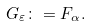<formula> <loc_0><loc_0><loc_500><loc_500>G _ { \varepsilon } \colon = F _ { \alpha } .</formula> 